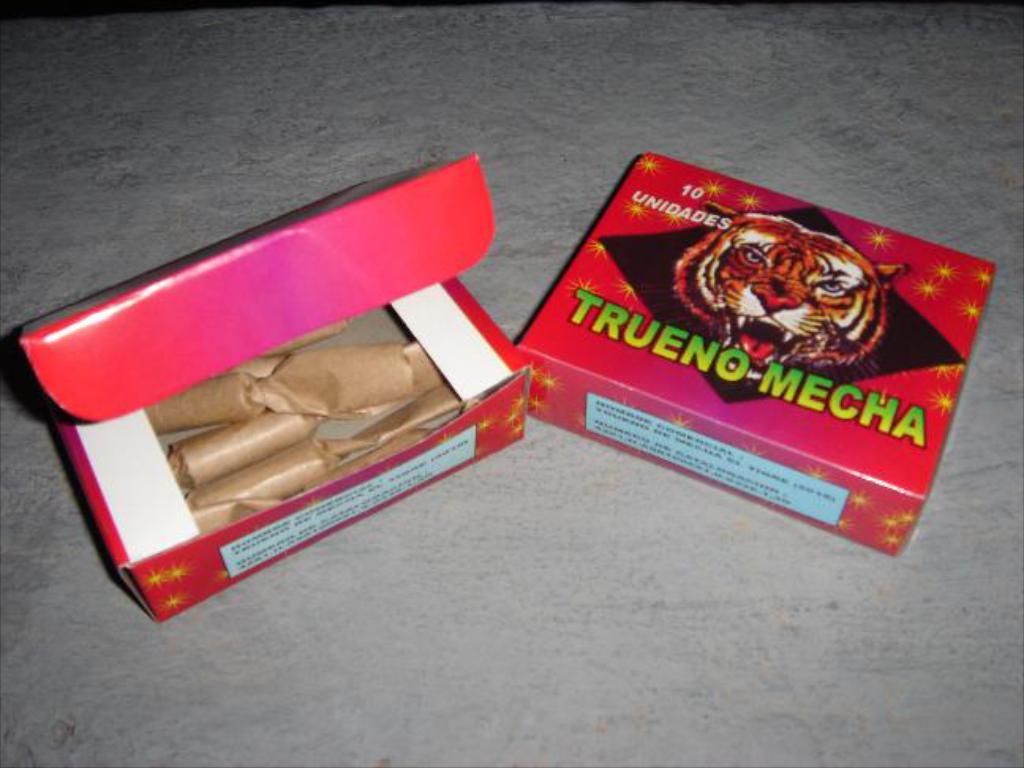What's the name of these fireworks?
Offer a terse response. Trueno-mecha. How many fireworks are in the box?
Your response must be concise. 10. 